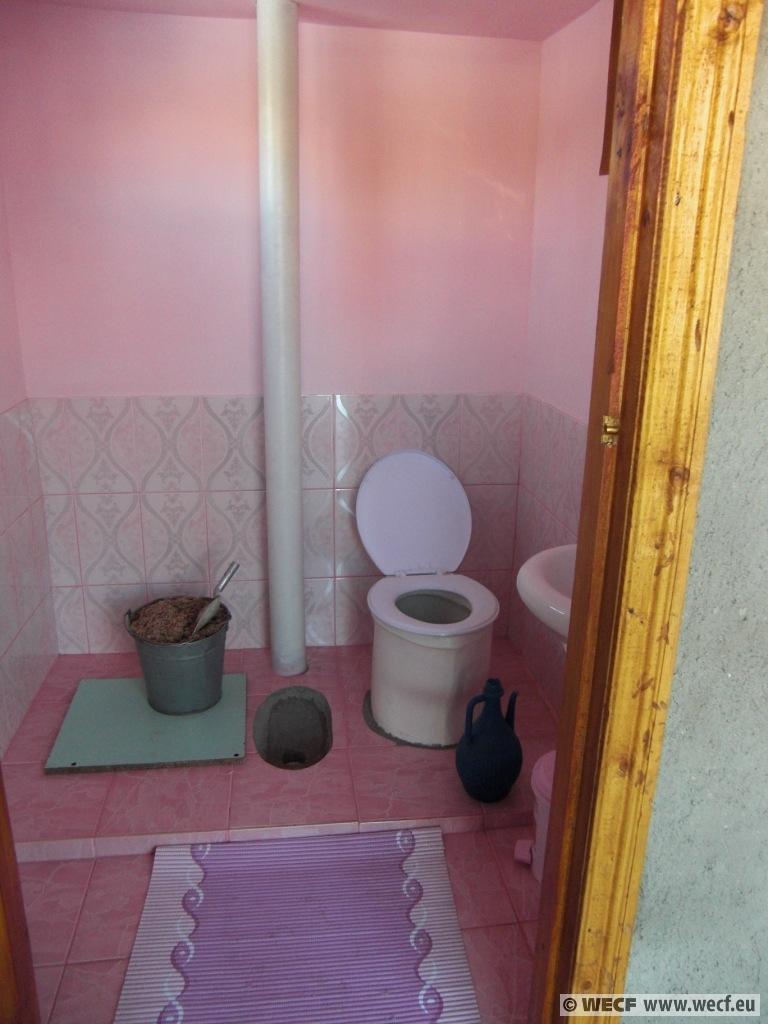In one or two sentences, can you explain what this image depicts? In the picture I can see an inner view of a bathroom. In the bathroom I can see white color pipe, a toilet seat, bucket and some other objects on the floor. The walls are pink in color. On the bottom right corner of the image I can see watermarks. 